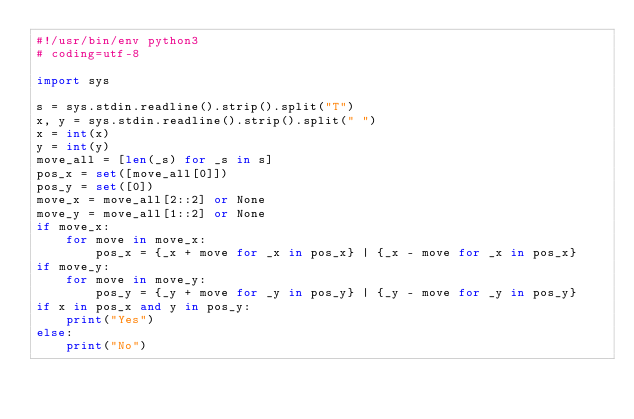<code> <loc_0><loc_0><loc_500><loc_500><_Python_>#!/usr/bin/env python3
# coding=utf-8

import sys

s = sys.stdin.readline().strip().split("T")
x, y = sys.stdin.readline().strip().split(" ")
x = int(x)
y = int(y)
move_all = [len(_s) for _s in s]
pos_x = set([move_all[0]])
pos_y = set([0])
move_x = move_all[2::2] or None
move_y = move_all[1::2] or None
if move_x:
    for move in move_x:
        pos_x = {_x + move for _x in pos_x} | {_x - move for _x in pos_x}
if move_y:
    for move in move_y:
        pos_y = {_y + move for _y in pos_y} | {_y - move for _y in pos_y}
if x in pos_x and y in pos_y:
    print("Yes")
else:
    print("No")
</code> 